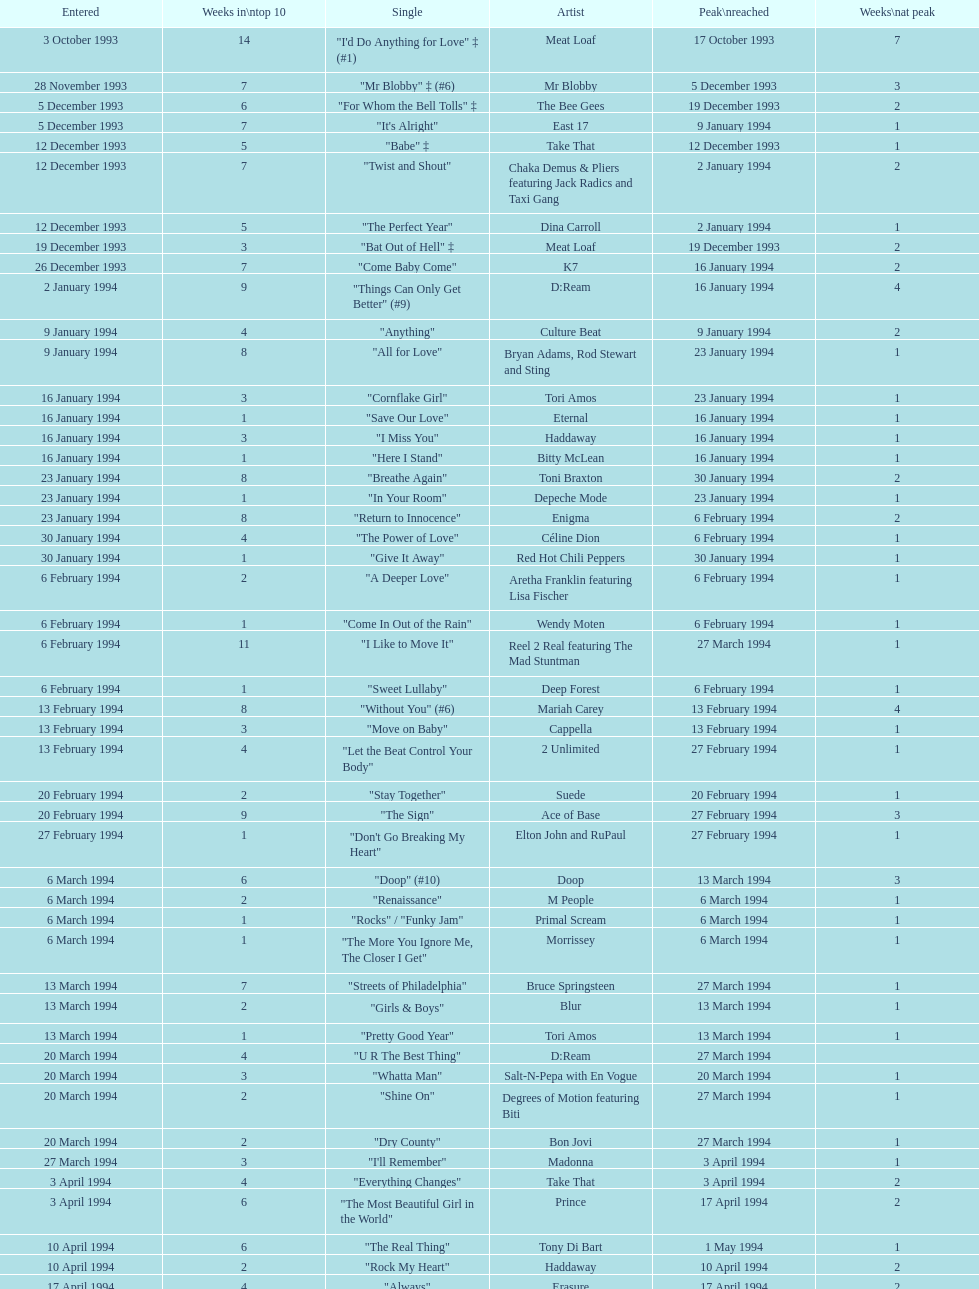Which artist came on the list after oasis? Tinman. 